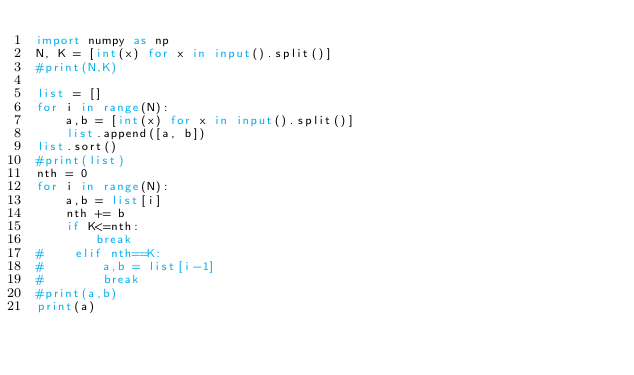Convert code to text. <code><loc_0><loc_0><loc_500><loc_500><_Python_>import numpy as np
N, K = [int(x) for x in input().split()]
#print(N,K)

list = []
for i in range(N):
    a,b = [int(x) for x in input().split()]
    list.append([a, b])
list.sort()
#print(list)
nth = 0
for i in range(N):
    a,b = list[i]
    nth += b 
    if K<=nth:
        break
#    elif nth==K:
#        a,b = list[i-1]
#        break
#print(a,b)
print(a)</code> 